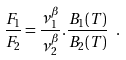<formula> <loc_0><loc_0><loc_500><loc_500>\frac { F _ { 1 } } { F _ { 2 } } = \frac { \nu _ { 1 } ^ { \beta } } { \nu _ { 2 } ^ { \beta } } . \frac { B _ { 1 } ( T ) } { B _ { 2 } ( T ) } \ .</formula> 